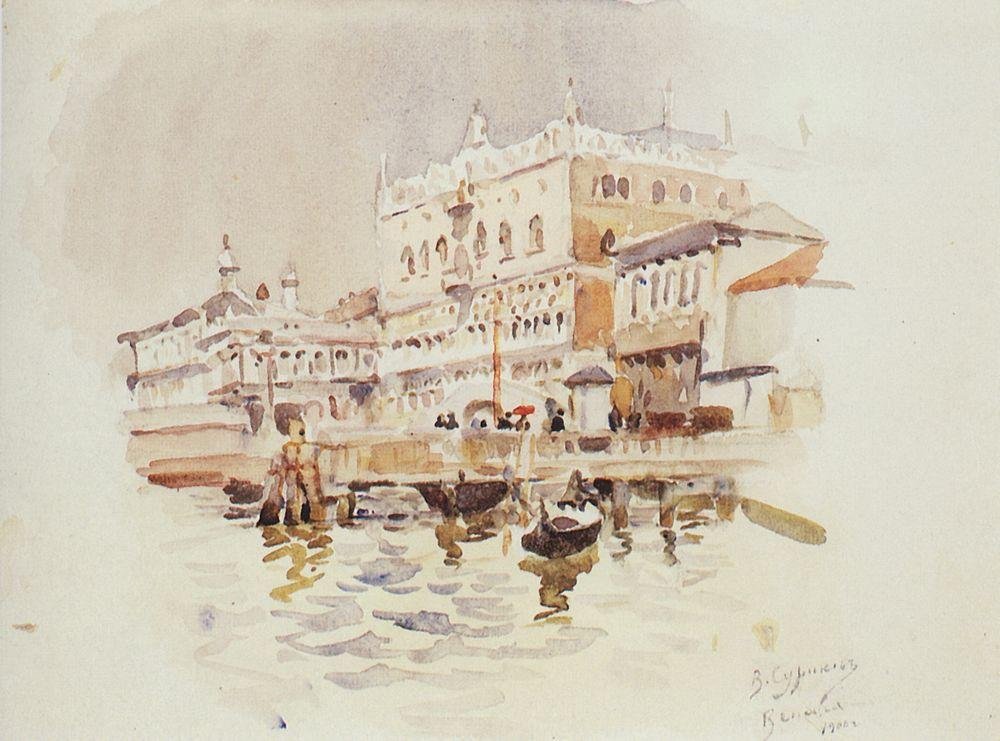How does the presence of boats in this scene add to our understanding of Venetian daily life? The boats are not just decorative elements; they represent the lifeline of Venice, a city built on canals where boats are a primary mode of transportation. Their presence in the painting accentuates the bustle of daily life, emphasizing how the waterways are veins of the city, pulsing with activity and connecting its people and commerce. 